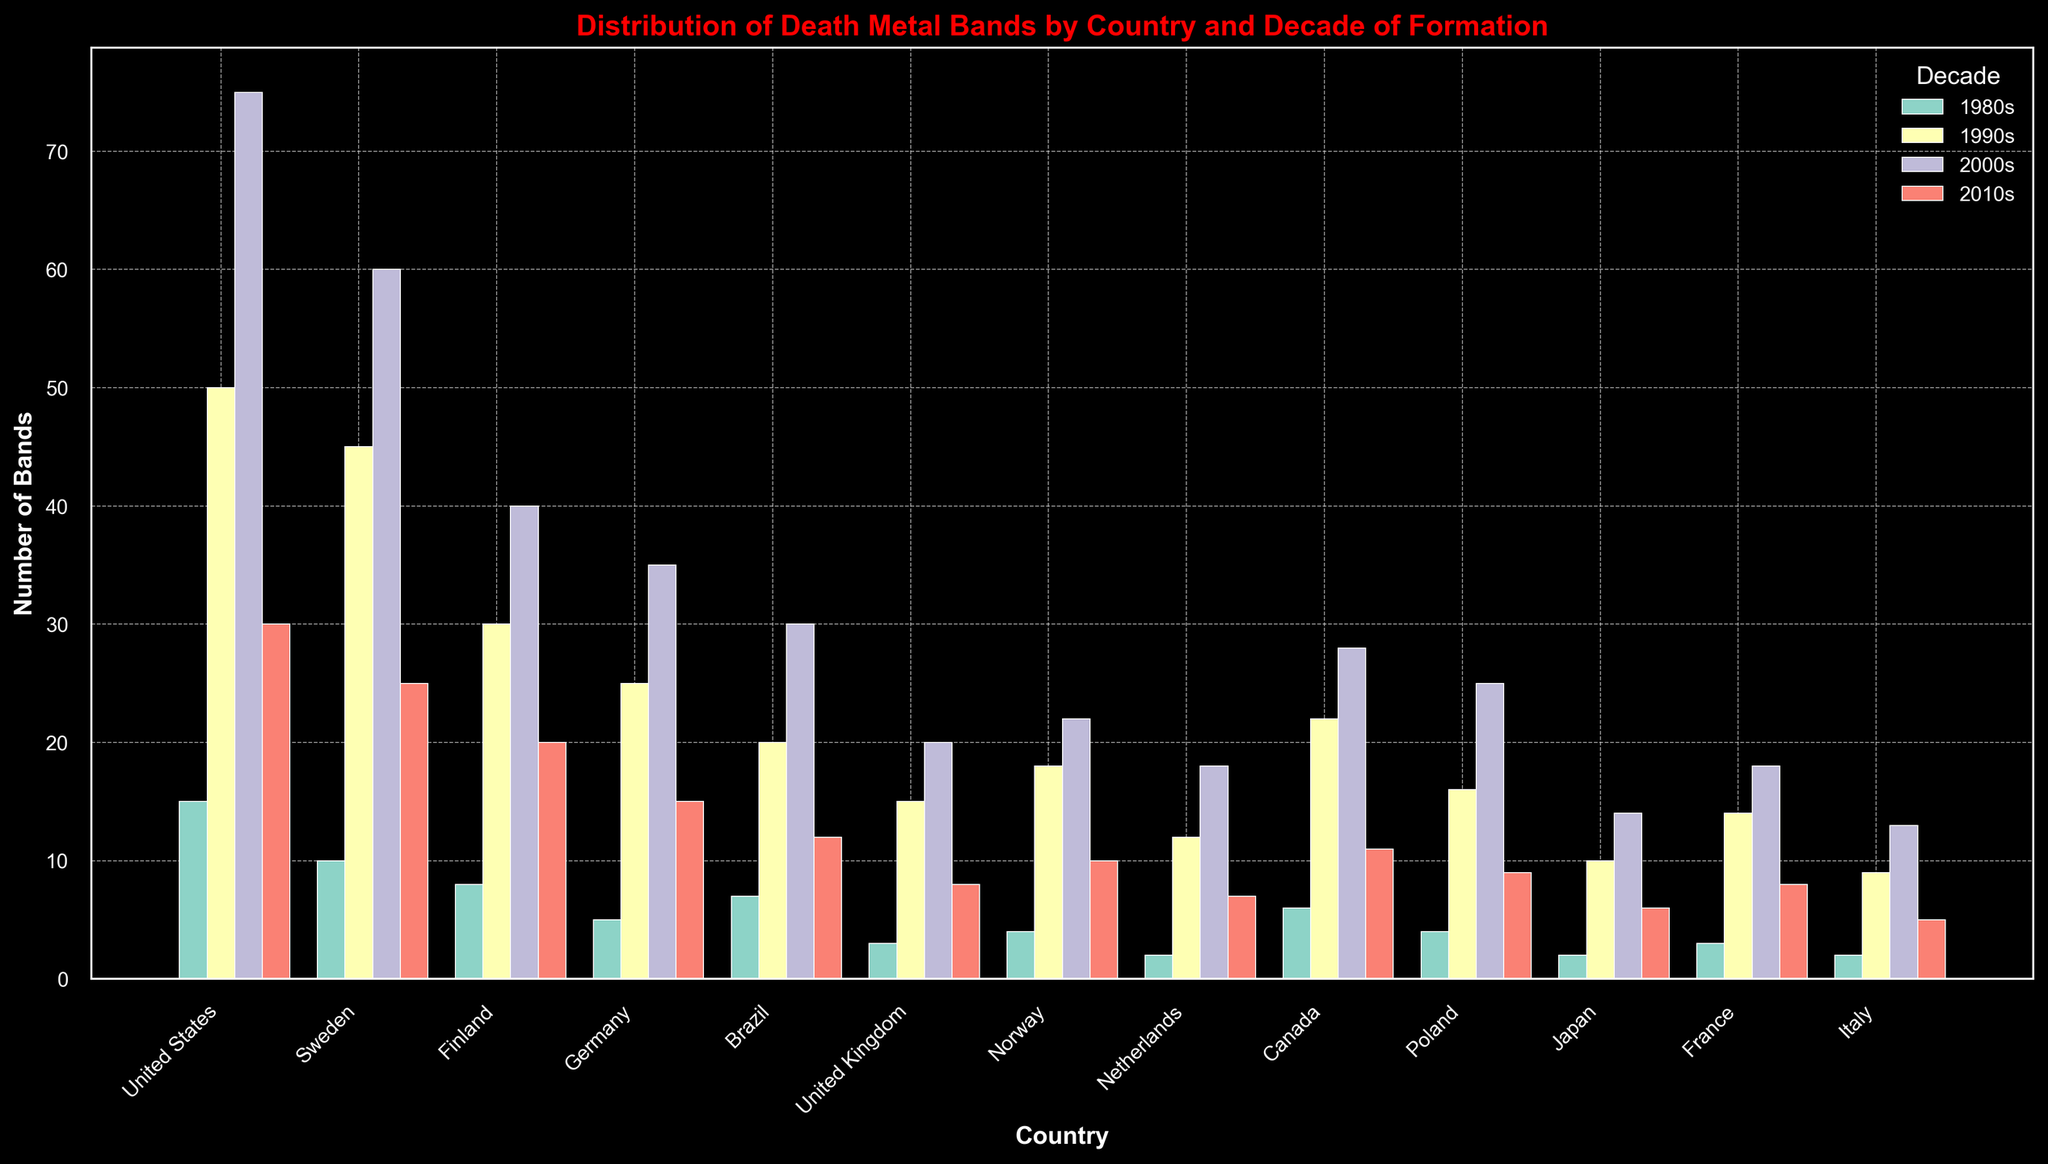Which country has the highest number of death metal bands formed in the 1990s? By looking at the height of the bars representing death metal bands formed in the 1990s for each country, the United States has the highest bar.
Answer: United States Which decade saw the formation of the most death metal bands in Sweden? Comparing the heights of the bars for each decade (1980s, 1990s, 2000s, 2010s) in Sweden, the 1990s bar is the tallest.
Answer: 1990s What is the total number of death metal bands formed in Finland across all decades? Sum up the number of bands formed in each decade for Finland: 8 (1980s) + 30 (1990s) + 40 (2000s) + 20 (2010s) = 98.
Answer: 98 How does the number of death metal bands formed in Brazil in the 1980s compare to the 2000s? Compare the heights of the bars for Brazil in the 1980s (7) and the 2000s (30), and the 2000s bar is significantly taller.
Answer: The 2000s had more bands Which country has the smallest number of bands formed in the 2010s? The shortest bar in the 2010s category across all countries belongs to Italy (5 bands).
Answer: Italy What is the combined total of death metal bands formed in Germany and Norway in the 1990s? Add the number of bands formed in the 1990s for both countries: Germany (25) + Norway (18) = 43.
Answer: 43 In which decade was there the biggest increase in the number of death metal bands formed in Canada? By comparing the heights of the bars for each decade for Canada, the significant increase is between the 1980s (6) and the 1990s (22).
Answer: 1990s Which country has the most balanced distribution of death metal bands across the decades? By looking at the countries with similar bar heights across the decades, Poland seems to have a relatively balanced distribution of bands (4, 16, 25, 9).
Answer: Poland What is the difference in the number of death metal bands formed in the United Kingdom between the 1980s and 1990s? Subtract the number of bands in the 1980s (3) from the 1990s (15): 15 - 3 = 12.
Answer: 12 Which country saw the highest growth in death metal bands formed from the 1980s to the 2000s? By comparing the increase in bar heights from the 1980s to the 2000s for each country, the United States shows the highest increase (from 15 to 75), a growth of 60 bands.
Answer: United States 